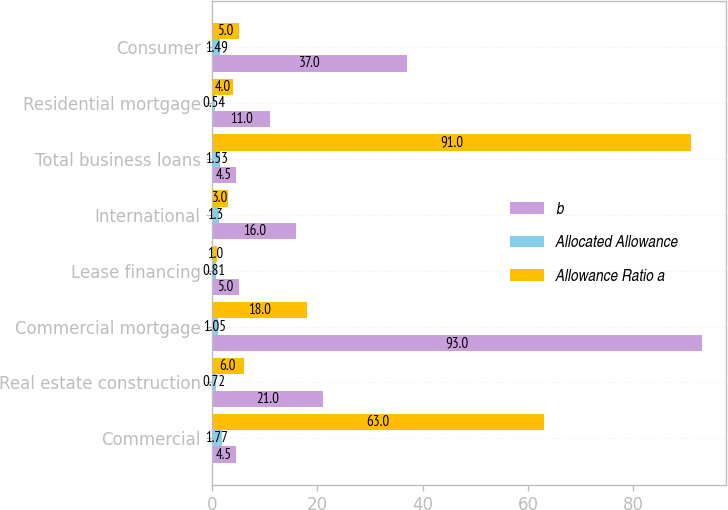Convert chart. <chart><loc_0><loc_0><loc_500><loc_500><stacked_bar_chart><ecel><fcel>Commercial<fcel>Real estate construction<fcel>Commercial mortgage<fcel>Lease financing<fcel>International<fcel>Total business loans<fcel>Residential mortgage<fcel>Consumer<nl><fcel>b<fcel>4.5<fcel>21<fcel>93<fcel>5<fcel>16<fcel>4.5<fcel>11<fcel>37<nl><fcel>Allocated Allowance<fcel>1.77<fcel>0.72<fcel>1.05<fcel>0.81<fcel>1.3<fcel>1.53<fcel>0.54<fcel>1.49<nl><fcel>Allowance Ratio a<fcel>63<fcel>6<fcel>18<fcel>1<fcel>3<fcel>91<fcel>4<fcel>5<nl></chart> 